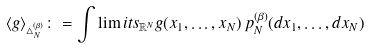Convert formula to latex. <formula><loc_0><loc_0><loc_500><loc_500>\langle g \rangle _ { \triangle _ { N } ^ { ( \beta ) } } \colon = \int \lim i t s _ { \mathbb { R } ^ { N } } g ( x _ { 1 } , \dots , x _ { N } ) \, p ^ { ( \beta ) } _ { N } ( d x _ { 1 } , \dots , d x _ { N } )</formula> 